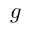<formula> <loc_0><loc_0><loc_500><loc_500>g</formula> 